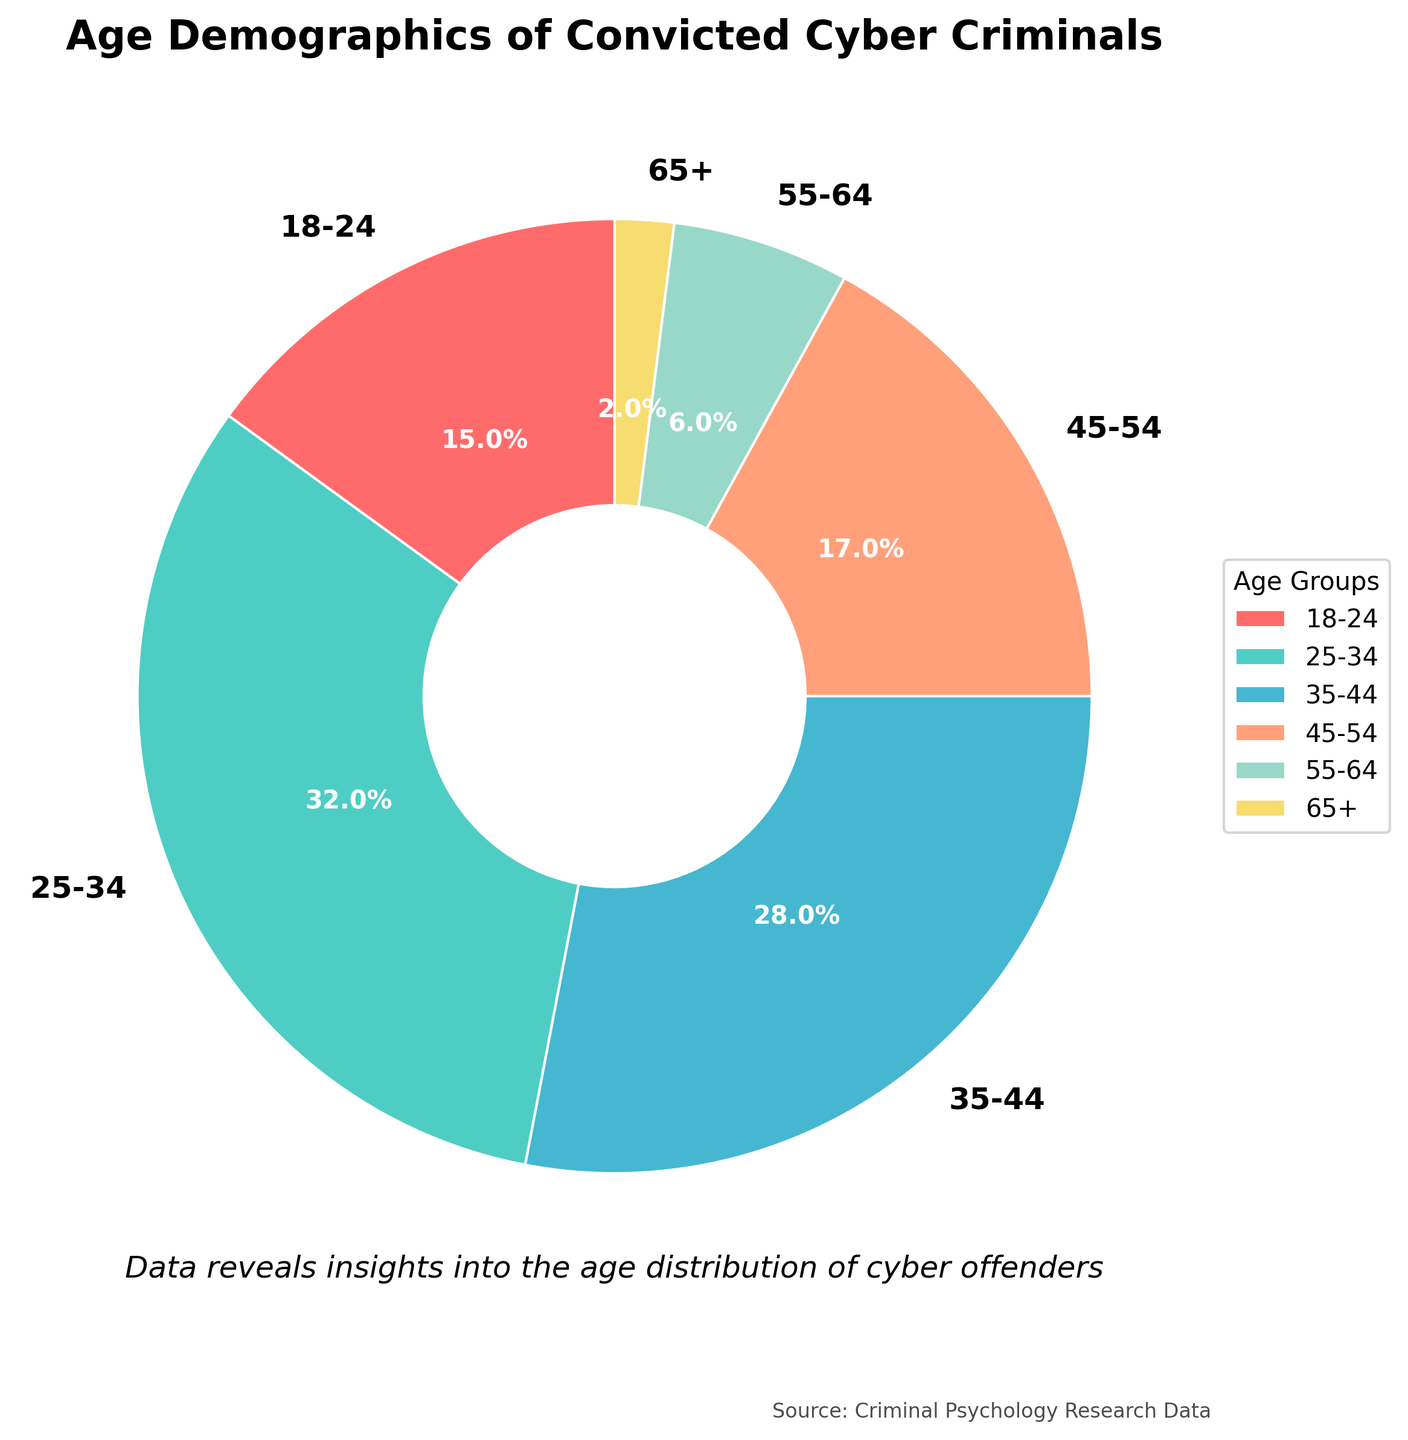What age group has the highest percentage of convicted cyber criminals? The age group with the highest percentage is clearly indicated by the largest wedge in the pie chart. From the legend and size comparison, the 25-34 age group has the largest wedge.
Answer: 25-34 Which two age groups combined account for over 50% of the convicted cyber criminals? By combining the percentages, we look for groups that sum up to more than 50%. The 25-34 age group is 32% and the 35-44 age group is 28%, which together make 60%, exceeding 50%.
Answer: 25-34 and 35-44 What is the percentage difference between the 18-24 age group and the 55-64 age group? The percentage of the 18-24 age group is 15% and the 55-64 age group is 6%. Subtract 6% from 15% to find the difference.
Answer: 9% Which age group has the smallest representation among convicted cyber criminals? The smallest wedge on the pie chart corresponds to the smallest percentage. According to the labels, the 65+ age group has the smallest percentage at 2%.
Answer: 65+ Is the combined percentage of the age groups 45-54 and 55-64 more or less than the percentage of the 35-44 age group? The 45-54 age group has 17% and the 55-64 age group has 6%. Summing these gives 23%. The 35-44 age group has 28%. Since 23% is less than 28%, the combined percentage is less.
Answer: Less What colors represent the age groups 18-24 and 25-34? By looking at the legend and the color mapping, the 18-24 age group is represented in red and the 25-34 age group is represented in green.
Answer: Red and Green Which two adjacent age groups (in terms of age range) together have the lowest percentage? Check adjacent groups' sums: 18-24 with 25-34, 25-34 with 35-44, 35-44 with 45-54, 45-54 with 55-64, and 55-64 with 65+. The smallest combination is 55-64 and 65+ at 6% and 2%, which totals to 8%.
Answer: 55-64 and 65+ Compare the percentage of the 45-54 age group with the sum of the 55-64 and 65+ age groups. Is it higher or lower? The 45-54 age group is 17%. The sum of the 55-64 and 65+ is 6% + 2% = 8%. Since 17% is greater than 8%, the 45-54 group is higher.
Answer: Higher 